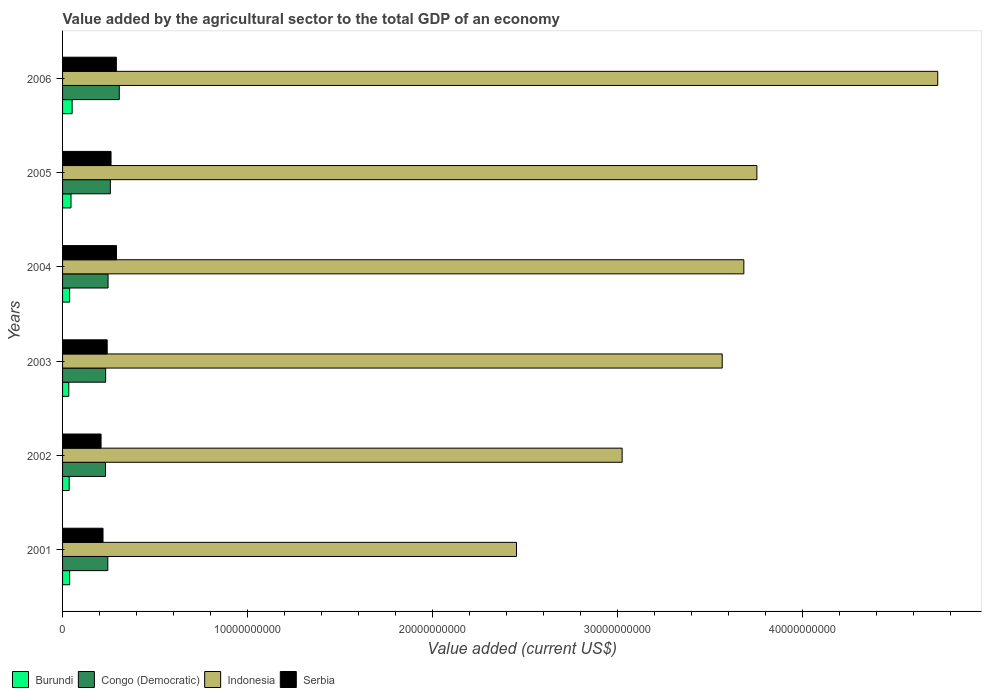How many different coloured bars are there?
Provide a succinct answer. 4. Are the number of bars per tick equal to the number of legend labels?
Your answer should be compact. Yes. What is the label of the 4th group of bars from the top?
Make the answer very short. 2003. In how many cases, is the number of bars for a given year not equal to the number of legend labels?
Keep it short and to the point. 0. What is the value added by the agricultural sector to the total GDP in Burundi in 2002?
Provide a succinct answer. 3.58e+08. Across all years, what is the maximum value added by the agricultural sector to the total GDP in Burundi?
Keep it short and to the point. 5.17e+08. Across all years, what is the minimum value added by the agricultural sector to the total GDP in Serbia?
Ensure brevity in your answer.  2.08e+09. In which year was the value added by the agricultural sector to the total GDP in Indonesia minimum?
Offer a terse response. 2001. What is the total value added by the agricultural sector to the total GDP in Serbia in the graph?
Offer a terse response. 1.51e+1. What is the difference between the value added by the agricultural sector to the total GDP in Serbia in 2001 and that in 2005?
Your answer should be very brief. -4.33e+08. What is the difference between the value added by the agricultural sector to the total GDP in Indonesia in 2001 and the value added by the agricultural sector to the total GDP in Serbia in 2003?
Give a very brief answer. 2.21e+1. What is the average value added by the agricultural sector to the total GDP in Indonesia per year?
Provide a succinct answer. 3.53e+1. In the year 2004, what is the difference between the value added by the agricultural sector to the total GDP in Indonesia and value added by the agricultural sector to the total GDP in Congo (Democratic)?
Your answer should be very brief. 3.44e+1. What is the ratio of the value added by the agricultural sector to the total GDP in Burundi in 2001 to that in 2002?
Your answer should be compact. 1.07. Is the value added by the agricultural sector to the total GDP in Burundi in 2004 less than that in 2005?
Make the answer very short. Yes. What is the difference between the highest and the second highest value added by the agricultural sector to the total GDP in Serbia?
Provide a short and direct response. 7.40e+06. What is the difference between the highest and the lowest value added by the agricultural sector to the total GDP in Serbia?
Give a very brief answer. 8.35e+08. In how many years, is the value added by the agricultural sector to the total GDP in Serbia greater than the average value added by the agricultural sector to the total GDP in Serbia taken over all years?
Ensure brevity in your answer.  3. Is the sum of the value added by the agricultural sector to the total GDP in Congo (Democratic) in 2002 and 2003 greater than the maximum value added by the agricultural sector to the total GDP in Indonesia across all years?
Offer a very short reply. No. Is it the case that in every year, the sum of the value added by the agricultural sector to the total GDP in Indonesia and value added by the agricultural sector to the total GDP in Congo (Democratic) is greater than the sum of value added by the agricultural sector to the total GDP in Burundi and value added by the agricultural sector to the total GDP in Serbia?
Offer a terse response. Yes. What does the 2nd bar from the top in 2001 represents?
Offer a terse response. Indonesia. Is it the case that in every year, the sum of the value added by the agricultural sector to the total GDP in Serbia and value added by the agricultural sector to the total GDP in Congo (Democratic) is greater than the value added by the agricultural sector to the total GDP in Burundi?
Your answer should be very brief. Yes. How many years are there in the graph?
Give a very brief answer. 6. What is the difference between two consecutive major ticks on the X-axis?
Give a very brief answer. 1.00e+1. How many legend labels are there?
Your answer should be very brief. 4. What is the title of the graph?
Offer a very short reply. Value added by the agricultural sector to the total GDP of an economy. What is the label or title of the X-axis?
Your response must be concise. Value added (current US$). What is the label or title of the Y-axis?
Offer a very short reply. Years. What is the Value added (current US$) in Burundi in 2001?
Give a very brief answer. 3.84e+08. What is the Value added (current US$) in Congo (Democratic) in 2001?
Provide a succinct answer. 2.44e+09. What is the Value added (current US$) in Indonesia in 2001?
Your answer should be very brief. 2.45e+1. What is the Value added (current US$) in Serbia in 2001?
Offer a terse response. 2.19e+09. What is the Value added (current US$) in Burundi in 2002?
Your answer should be compact. 3.58e+08. What is the Value added (current US$) in Congo (Democratic) in 2002?
Provide a short and direct response. 2.32e+09. What is the Value added (current US$) of Indonesia in 2002?
Your answer should be very brief. 3.02e+1. What is the Value added (current US$) of Serbia in 2002?
Give a very brief answer. 2.08e+09. What is the Value added (current US$) of Burundi in 2003?
Make the answer very short. 3.36e+08. What is the Value added (current US$) of Congo (Democratic) in 2003?
Your response must be concise. 2.33e+09. What is the Value added (current US$) in Indonesia in 2003?
Provide a short and direct response. 3.57e+1. What is the Value added (current US$) in Serbia in 2003?
Keep it short and to the point. 2.41e+09. What is the Value added (current US$) of Burundi in 2004?
Your response must be concise. 3.84e+08. What is the Value added (current US$) in Congo (Democratic) in 2004?
Make the answer very short. 2.46e+09. What is the Value added (current US$) of Indonesia in 2004?
Give a very brief answer. 3.68e+1. What is the Value added (current US$) in Serbia in 2004?
Provide a short and direct response. 2.92e+09. What is the Value added (current US$) of Burundi in 2005?
Your answer should be very brief. 4.56e+08. What is the Value added (current US$) of Congo (Democratic) in 2005?
Offer a terse response. 2.58e+09. What is the Value added (current US$) in Indonesia in 2005?
Ensure brevity in your answer.  3.75e+1. What is the Value added (current US$) of Serbia in 2005?
Ensure brevity in your answer.  2.62e+09. What is the Value added (current US$) in Burundi in 2006?
Provide a short and direct response. 5.17e+08. What is the Value added (current US$) in Congo (Democratic) in 2006?
Offer a terse response. 3.07e+09. What is the Value added (current US$) in Indonesia in 2006?
Keep it short and to the point. 4.73e+1. What is the Value added (current US$) of Serbia in 2006?
Ensure brevity in your answer.  2.91e+09. Across all years, what is the maximum Value added (current US$) of Burundi?
Your response must be concise. 5.17e+08. Across all years, what is the maximum Value added (current US$) of Congo (Democratic)?
Offer a very short reply. 3.07e+09. Across all years, what is the maximum Value added (current US$) of Indonesia?
Keep it short and to the point. 4.73e+1. Across all years, what is the maximum Value added (current US$) of Serbia?
Give a very brief answer. 2.92e+09. Across all years, what is the minimum Value added (current US$) in Burundi?
Provide a succinct answer. 3.36e+08. Across all years, what is the minimum Value added (current US$) of Congo (Democratic)?
Provide a short and direct response. 2.32e+09. Across all years, what is the minimum Value added (current US$) of Indonesia?
Your response must be concise. 2.45e+1. Across all years, what is the minimum Value added (current US$) of Serbia?
Ensure brevity in your answer.  2.08e+09. What is the total Value added (current US$) of Burundi in the graph?
Offer a very short reply. 2.44e+09. What is the total Value added (current US$) of Congo (Democratic) in the graph?
Give a very brief answer. 1.52e+1. What is the total Value added (current US$) in Indonesia in the graph?
Give a very brief answer. 2.12e+11. What is the total Value added (current US$) of Serbia in the graph?
Your response must be concise. 1.51e+1. What is the difference between the Value added (current US$) in Burundi in 2001 and that in 2002?
Your answer should be very brief. 2.67e+07. What is the difference between the Value added (current US$) of Congo (Democratic) in 2001 and that in 2002?
Give a very brief answer. 1.25e+08. What is the difference between the Value added (current US$) in Indonesia in 2001 and that in 2002?
Offer a terse response. -5.71e+09. What is the difference between the Value added (current US$) in Serbia in 2001 and that in 2002?
Your answer should be compact. 1.06e+08. What is the difference between the Value added (current US$) in Burundi in 2001 and that in 2003?
Offer a terse response. 4.83e+07. What is the difference between the Value added (current US$) in Congo (Democratic) in 2001 and that in 2003?
Give a very brief answer. 1.16e+08. What is the difference between the Value added (current US$) of Indonesia in 2001 and that in 2003?
Ensure brevity in your answer.  -1.11e+1. What is the difference between the Value added (current US$) in Serbia in 2001 and that in 2003?
Give a very brief answer. -2.26e+08. What is the difference between the Value added (current US$) of Burundi in 2001 and that in 2004?
Make the answer very short. 8.98e+05. What is the difference between the Value added (current US$) of Congo (Democratic) in 2001 and that in 2004?
Your response must be concise. -1.40e+07. What is the difference between the Value added (current US$) of Indonesia in 2001 and that in 2004?
Provide a succinct answer. -1.23e+1. What is the difference between the Value added (current US$) in Serbia in 2001 and that in 2004?
Offer a very short reply. -7.29e+08. What is the difference between the Value added (current US$) in Burundi in 2001 and that in 2005?
Provide a succinct answer. -7.20e+07. What is the difference between the Value added (current US$) of Congo (Democratic) in 2001 and that in 2005?
Give a very brief answer. -1.37e+08. What is the difference between the Value added (current US$) of Indonesia in 2001 and that in 2005?
Keep it short and to the point. -1.30e+1. What is the difference between the Value added (current US$) of Serbia in 2001 and that in 2005?
Give a very brief answer. -4.33e+08. What is the difference between the Value added (current US$) of Burundi in 2001 and that in 2006?
Provide a short and direct response. -1.33e+08. What is the difference between the Value added (current US$) of Congo (Democratic) in 2001 and that in 2006?
Provide a short and direct response. -6.20e+08. What is the difference between the Value added (current US$) of Indonesia in 2001 and that in 2006?
Your response must be concise. -2.28e+1. What is the difference between the Value added (current US$) in Serbia in 2001 and that in 2006?
Keep it short and to the point. -7.22e+08. What is the difference between the Value added (current US$) in Burundi in 2002 and that in 2003?
Provide a short and direct response. 2.15e+07. What is the difference between the Value added (current US$) in Congo (Democratic) in 2002 and that in 2003?
Your answer should be very brief. -8.34e+06. What is the difference between the Value added (current US$) of Indonesia in 2002 and that in 2003?
Provide a short and direct response. -5.41e+09. What is the difference between the Value added (current US$) of Serbia in 2002 and that in 2003?
Ensure brevity in your answer.  -3.32e+08. What is the difference between the Value added (current US$) of Burundi in 2002 and that in 2004?
Ensure brevity in your answer.  -2.58e+07. What is the difference between the Value added (current US$) in Congo (Democratic) in 2002 and that in 2004?
Keep it short and to the point. -1.39e+08. What is the difference between the Value added (current US$) in Indonesia in 2002 and that in 2004?
Your answer should be compact. -6.58e+09. What is the difference between the Value added (current US$) of Serbia in 2002 and that in 2004?
Ensure brevity in your answer.  -8.35e+08. What is the difference between the Value added (current US$) in Burundi in 2002 and that in 2005?
Your response must be concise. -9.87e+07. What is the difference between the Value added (current US$) of Congo (Democratic) in 2002 and that in 2005?
Provide a succinct answer. -2.62e+08. What is the difference between the Value added (current US$) in Indonesia in 2002 and that in 2005?
Provide a succinct answer. -7.28e+09. What is the difference between the Value added (current US$) in Serbia in 2002 and that in 2005?
Give a very brief answer. -5.39e+08. What is the difference between the Value added (current US$) in Burundi in 2002 and that in 2006?
Your answer should be very brief. -1.60e+08. What is the difference between the Value added (current US$) of Congo (Democratic) in 2002 and that in 2006?
Make the answer very short. -7.45e+08. What is the difference between the Value added (current US$) of Indonesia in 2002 and that in 2006?
Make the answer very short. -1.71e+1. What is the difference between the Value added (current US$) in Serbia in 2002 and that in 2006?
Provide a short and direct response. -8.27e+08. What is the difference between the Value added (current US$) of Burundi in 2003 and that in 2004?
Offer a terse response. -4.74e+07. What is the difference between the Value added (current US$) in Congo (Democratic) in 2003 and that in 2004?
Your response must be concise. -1.30e+08. What is the difference between the Value added (current US$) in Indonesia in 2003 and that in 2004?
Give a very brief answer. -1.17e+09. What is the difference between the Value added (current US$) in Serbia in 2003 and that in 2004?
Keep it short and to the point. -5.03e+08. What is the difference between the Value added (current US$) of Burundi in 2003 and that in 2005?
Give a very brief answer. -1.20e+08. What is the difference between the Value added (current US$) of Congo (Democratic) in 2003 and that in 2005?
Your response must be concise. -2.53e+08. What is the difference between the Value added (current US$) in Indonesia in 2003 and that in 2005?
Ensure brevity in your answer.  -1.87e+09. What is the difference between the Value added (current US$) in Serbia in 2003 and that in 2005?
Ensure brevity in your answer.  -2.07e+08. What is the difference between the Value added (current US$) in Burundi in 2003 and that in 2006?
Your answer should be compact. -1.81e+08. What is the difference between the Value added (current US$) in Congo (Democratic) in 2003 and that in 2006?
Provide a short and direct response. -7.37e+08. What is the difference between the Value added (current US$) in Indonesia in 2003 and that in 2006?
Give a very brief answer. -1.16e+1. What is the difference between the Value added (current US$) of Serbia in 2003 and that in 2006?
Give a very brief answer. -4.96e+08. What is the difference between the Value added (current US$) of Burundi in 2004 and that in 2005?
Make the answer very short. -7.29e+07. What is the difference between the Value added (current US$) in Congo (Democratic) in 2004 and that in 2005?
Your response must be concise. -1.23e+08. What is the difference between the Value added (current US$) in Indonesia in 2004 and that in 2005?
Provide a short and direct response. -7.05e+08. What is the difference between the Value added (current US$) in Serbia in 2004 and that in 2005?
Give a very brief answer. 2.96e+08. What is the difference between the Value added (current US$) of Burundi in 2004 and that in 2006?
Your answer should be very brief. -1.34e+08. What is the difference between the Value added (current US$) in Congo (Democratic) in 2004 and that in 2006?
Give a very brief answer. -6.06e+08. What is the difference between the Value added (current US$) of Indonesia in 2004 and that in 2006?
Give a very brief answer. -1.05e+1. What is the difference between the Value added (current US$) of Serbia in 2004 and that in 2006?
Offer a very short reply. 7.40e+06. What is the difference between the Value added (current US$) of Burundi in 2005 and that in 2006?
Ensure brevity in your answer.  -6.11e+07. What is the difference between the Value added (current US$) of Congo (Democratic) in 2005 and that in 2006?
Give a very brief answer. -4.83e+08. What is the difference between the Value added (current US$) in Indonesia in 2005 and that in 2006?
Give a very brief answer. -9.77e+09. What is the difference between the Value added (current US$) of Serbia in 2005 and that in 2006?
Your response must be concise. -2.88e+08. What is the difference between the Value added (current US$) in Burundi in 2001 and the Value added (current US$) in Congo (Democratic) in 2002?
Ensure brevity in your answer.  -1.94e+09. What is the difference between the Value added (current US$) of Burundi in 2001 and the Value added (current US$) of Indonesia in 2002?
Give a very brief answer. -2.99e+1. What is the difference between the Value added (current US$) in Burundi in 2001 and the Value added (current US$) in Serbia in 2002?
Make the answer very short. -1.70e+09. What is the difference between the Value added (current US$) in Congo (Democratic) in 2001 and the Value added (current US$) in Indonesia in 2002?
Offer a terse response. -2.78e+1. What is the difference between the Value added (current US$) of Congo (Democratic) in 2001 and the Value added (current US$) of Serbia in 2002?
Your answer should be very brief. 3.65e+08. What is the difference between the Value added (current US$) of Indonesia in 2001 and the Value added (current US$) of Serbia in 2002?
Ensure brevity in your answer.  2.25e+1. What is the difference between the Value added (current US$) of Burundi in 2001 and the Value added (current US$) of Congo (Democratic) in 2003?
Provide a succinct answer. -1.94e+09. What is the difference between the Value added (current US$) in Burundi in 2001 and the Value added (current US$) in Indonesia in 2003?
Provide a succinct answer. -3.53e+1. What is the difference between the Value added (current US$) in Burundi in 2001 and the Value added (current US$) in Serbia in 2003?
Your answer should be very brief. -2.03e+09. What is the difference between the Value added (current US$) in Congo (Democratic) in 2001 and the Value added (current US$) in Indonesia in 2003?
Offer a very short reply. -3.32e+1. What is the difference between the Value added (current US$) of Congo (Democratic) in 2001 and the Value added (current US$) of Serbia in 2003?
Give a very brief answer. 3.29e+07. What is the difference between the Value added (current US$) in Indonesia in 2001 and the Value added (current US$) in Serbia in 2003?
Provide a succinct answer. 2.21e+1. What is the difference between the Value added (current US$) in Burundi in 2001 and the Value added (current US$) in Congo (Democratic) in 2004?
Your response must be concise. -2.07e+09. What is the difference between the Value added (current US$) of Burundi in 2001 and the Value added (current US$) of Indonesia in 2004?
Make the answer very short. -3.64e+1. What is the difference between the Value added (current US$) in Burundi in 2001 and the Value added (current US$) in Serbia in 2004?
Give a very brief answer. -2.53e+09. What is the difference between the Value added (current US$) of Congo (Democratic) in 2001 and the Value added (current US$) of Indonesia in 2004?
Keep it short and to the point. -3.44e+1. What is the difference between the Value added (current US$) of Congo (Democratic) in 2001 and the Value added (current US$) of Serbia in 2004?
Your answer should be compact. -4.70e+08. What is the difference between the Value added (current US$) of Indonesia in 2001 and the Value added (current US$) of Serbia in 2004?
Provide a short and direct response. 2.16e+1. What is the difference between the Value added (current US$) in Burundi in 2001 and the Value added (current US$) in Congo (Democratic) in 2005?
Provide a succinct answer. -2.20e+09. What is the difference between the Value added (current US$) in Burundi in 2001 and the Value added (current US$) in Indonesia in 2005?
Your response must be concise. -3.71e+1. What is the difference between the Value added (current US$) in Burundi in 2001 and the Value added (current US$) in Serbia in 2005?
Ensure brevity in your answer.  -2.24e+09. What is the difference between the Value added (current US$) in Congo (Democratic) in 2001 and the Value added (current US$) in Indonesia in 2005?
Your answer should be very brief. -3.51e+1. What is the difference between the Value added (current US$) in Congo (Democratic) in 2001 and the Value added (current US$) in Serbia in 2005?
Offer a terse response. -1.75e+08. What is the difference between the Value added (current US$) of Indonesia in 2001 and the Value added (current US$) of Serbia in 2005?
Give a very brief answer. 2.19e+1. What is the difference between the Value added (current US$) in Burundi in 2001 and the Value added (current US$) in Congo (Democratic) in 2006?
Make the answer very short. -2.68e+09. What is the difference between the Value added (current US$) of Burundi in 2001 and the Value added (current US$) of Indonesia in 2006?
Make the answer very short. -4.69e+1. What is the difference between the Value added (current US$) in Burundi in 2001 and the Value added (current US$) in Serbia in 2006?
Offer a terse response. -2.52e+09. What is the difference between the Value added (current US$) of Congo (Democratic) in 2001 and the Value added (current US$) of Indonesia in 2006?
Keep it short and to the point. -4.49e+1. What is the difference between the Value added (current US$) in Congo (Democratic) in 2001 and the Value added (current US$) in Serbia in 2006?
Provide a short and direct response. -4.63e+08. What is the difference between the Value added (current US$) in Indonesia in 2001 and the Value added (current US$) in Serbia in 2006?
Offer a terse response. 2.16e+1. What is the difference between the Value added (current US$) of Burundi in 2002 and the Value added (current US$) of Congo (Democratic) in 2003?
Make the answer very short. -1.97e+09. What is the difference between the Value added (current US$) in Burundi in 2002 and the Value added (current US$) in Indonesia in 2003?
Give a very brief answer. -3.53e+1. What is the difference between the Value added (current US$) of Burundi in 2002 and the Value added (current US$) of Serbia in 2003?
Provide a short and direct response. -2.05e+09. What is the difference between the Value added (current US$) in Congo (Democratic) in 2002 and the Value added (current US$) in Indonesia in 2003?
Provide a short and direct response. -3.33e+1. What is the difference between the Value added (current US$) in Congo (Democratic) in 2002 and the Value added (current US$) in Serbia in 2003?
Provide a succinct answer. -9.18e+07. What is the difference between the Value added (current US$) of Indonesia in 2002 and the Value added (current US$) of Serbia in 2003?
Make the answer very short. 2.78e+1. What is the difference between the Value added (current US$) of Burundi in 2002 and the Value added (current US$) of Congo (Democratic) in 2004?
Give a very brief answer. -2.10e+09. What is the difference between the Value added (current US$) in Burundi in 2002 and the Value added (current US$) in Indonesia in 2004?
Keep it short and to the point. -3.65e+1. What is the difference between the Value added (current US$) in Burundi in 2002 and the Value added (current US$) in Serbia in 2004?
Provide a short and direct response. -2.56e+09. What is the difference between the Value added (current US$) of Congo (Democratic) in 2002 and the Value added (current US$) of Indonesia in 2004?
Ensure brevity in your answer.  -3.45e+1. What is the difference between the Value added (current US$) in Congo (Democratic) in 2002 and the Value added (current US$) in Serbia in 2004?
Offer a terse response. -5.95e+08. What is the difference between the Value added (current US$) in Indonesia in 2002 and the Value added (current US$) in Serbia in 2004?
Your answer should be very brief. 2.73e+1. What is the difference between the Value added (current US$) in Burundi in 2002 and the Value added (current US$) in Congo (Democratic) in 2005?
Ensure brevity in your answer.  -2.22e+09. What is the difference between the Value added (current US$) of Burundi in 2002 and the Value added (current US$) of Indonesia in 2005?
Offer a very short reply. -3.72e+1. What is the difference between the Value added (current US$) in Burundi in 2002 and the Value added (current US$) in Serbia in 2005?
Your response must be concise. -2.26e+09. What is the difference between the Value added (current US$) in Congo (Democratic) in 2002 and the Value added (current US$) in Indonesia in 2005?
Provide a succinct answer. -3.52e+1. What is the difference between the Value added (current US$) of Congo (Democratic) in 2002 and the Value added (current US$) of Serbia in 2005?
Provide a succinct answer. -2.99e+08. What is the difference between the Value added (current US$) in Indonesia in 2002 and the Value added (current US$) in Serbia in 2005?
Offer a very short reply. 2.76e+1. What is the difference between the Value added (current US$) in Burundi in 2002 and the Value added (current US$) in Congo (Democratic) in 2006?
Provide a short and direct response. -2.71e+09. What is the difference between the Value added (current US$) in Burundi in 2002 and the Value added (current US$) in Indonesia in 2006?
Offer a very short reply. -4.69e+1. What is the difference between the Value added (current US$) of Burundi in 2002 and the Value added (current US$) of Serbia in 2006?
Give a very brief answer. -2.55e+09. What is the difference between the Value added (current US$) of Congo (Democratic) in 2002 and the Value added (current US$) of Indonesia in 2006?
Make the answer very short. -4.50e+1. What is the difference between the Value added (current US$) in Congo (Democratic) in 2002 and the Value added (current US$) in Serbia in 2006?
Your answer should be compact. -5.87e+08. What is the difference between the Value added (current US$) in Indonesia in 2002 and the Value added (current US$) in Serbia in 2006?
Offer a very short reply. 2.73e+1. What is the difference between the Value added (current US$) in Burundi in 2003 and the Value added (current US$) in Congo (Democratic) in 2004?
Your answer should be very brief. -2.12e+09. What is the difference between the Value added (current US$) of Burundi in 2003 and the Value added (current US$) of Indonesia in 2004?
Offer a terse response. -3.65e+1. What is the difference between the Value added (current US$) in Burundi in 2003 and the Value added (current US$) in Serbia in 2004?
Make the answer very short. -2.58e+09. What is the difference between the Value added (current US$) of Congo (Democratic) in 2003 and the Value added (current US$) of Indonesia in 2004?
Give a very brief answer. -3.45e+1. What is the difference between the Value added (current US$) of Congo (Democratic) in 2003 and the Value added (current US$) of Serbia in 2004?
Keep it short and to the point. -5.86e+08. What is the difference between the Value added (current US$) in Indonesia in 2003 and the Value added (current US$) in Serbia in 2004?
Your response must be concise. 3.27e+1. What is the difference between the Value added (current US$) in Burundi in 2003 and the Value added (current US$) in Congo (Democratic) in 2005?
Keep it short and to the point. -2.25e+09. What is the difference between the Value added (current US$) in Burundi in 2003 and the Value added (current US$) in Indonesia in 2005?
Give a very brief answer. -3.72e+1. What is the difference between the Value added (current US$) in Burundi in 2003 and the Value added (current US$) in Serbia in 2005?
Ensure brevity in your answer.  -2.28e+09. What is the difference between the Value added (current US$) in Congo (Democratic) in 2003 and the Value added (current US$) in Indonesia in 2005?
Your response must be concise. -3.52e+1. What is the difference between the Value added (current US$) in Congo (Democratic) in 2003 and the Value added (current US$) in Serbia in 2005?
Make the answer very short. -2.91e+08. What is the difference between the Value added (current US$) of Indonesia in 2003 and the Value added (current US$) of Serbia in 2005?
Your response must be concise. 3.30e+1. What is the difference between the Value added (current US$) in Burundi in 2003 and the Value added (current US$) in Congo (Democratic) in 2006?
Your answer should be compact. -2.73e+09. What is the difference between the Value added (current US$) in Burundi in 2003 and the Value added (current US$) in Indonesia in 2006?
Give a very brief answer. -4.70e+1. What is the difference between the Value added (current US$) of Burundi in 2003 and the Value added (current US$) of Serbia in 2006?
Make the answer very short. -2.57e+09. What is the difference between the Value added (current US$) of Congo (Democratic) in 2003 and the Value added (current US$) of Indonesia in 2006?
Your answer should be very brief. -4.50e+1. What is the difference between the Value added (current US$) in Congo (Democratic) in 2003 and the Value added (current US$) in Serbia in 2006?
Ensure brevity in your answer.  -5.79e+08. What is the difference between the Value added (current US$) in Indonesia in 2003 and the Value added (current US$) in Serbia in 2006?
Your answer should be very brief. 3.27e+1. What is the difference between the Value added (current US$) of Burundi in 2004 and the Value added (current US$) of Congo (Democratic) in 2005?
Your answer should be very brief. -2.20e+09. What is the difference between the Value added (current US$) in Burundi in 2004 and the Value added (current US$) in Indonesia in 2005?
Provide a short and direct response. -3.71e+1. What is the difference between the Value added (current US$) of Burundi in 2004 and the Value added (current US$) of Serbia in 2005?
Make the answer very short. -2.24e+09. What is the difference between the Value added (current US$) of Congo (Democratic) in 2004 and the Value added (current US$) of Indonesia in 2005?
Make the answer very short. -3.51e+1. What is the difference between the Value added (current US$) in Congo (Democratic) in 2004 and the Value added (current US$) in Serbia in 2005?
Your response must be concise. -1.61e+08. What is the difference between the Value added (current US$) in Indonesia in 2004 and the Value added (current US$) in Serbia in 2005?
Give a very brief answer. 3.42e+1. What is the difference between the Value added (current US$) in Burundi in 2004 and the Value added (current US$) in Congo (Democratic) in 2006?
Your answer should be very brief. -2.68e+09. What is the difference between the Value added (current US$) in Burundi in 2004 and the Value added (current US$) in Indonesia in 2006?
Your answer should be compact. -4.69e+1. What is the difference between the Value added (current US$) in Burundi in 2004 and the Value added (current US$) in Serbia in 2006?
Keep it short and to the point. -2.52e+09. What is the difference between the Value added (current US$) in Congo (Democratic) in 2004 and the Value added (current US$) in Indonesia in 2006?
Provide a succinct answer. -4.48e+1. What is the difference between the Value added (current US$) of Congo (Democratic) in 2004 and the Value added (current US$) of Serbia in 2006?
Your response must be concise. -4.49e+08. What is the difference between the Value added (current US$) in Indonesia in 2004 and the Value added (current US$) in Serbia in 2006?
Make the answer very short. 3.39e+1. What is the difference between the Value added (current US$) of Burundi in 2005 and the Value added (current US$) of Congo (Democratic) in 2006?
Offer a very short reply. -2.61e+09. What is the difference between the Value added (current US$) of Burundi in 2005 and the Value added (current US$) of Indonesia in 2006?
Provide a short and direct response. -4.68e+1. What is the difference between the Value added (current US$) in Burundi in 2005 and the Value added (current US$) in Serbia in 2006?
Make the answer very short. -2.45e+09. What is the difference between the Value added (current US$) of Congo (Democratic) in 2005 and the Value added (current US$) of Indonesia in 2006?
Provide a succinct answer. -4.47e+1. What is the difference between the Value added (current US$) in Congo (Democratic) in 2005 and the Value added (current US$) in Serbia in 2006?
Keep it short and to the point. -3.26e+08. What is the difference between the Value added (current US$) in Indonesia in 2005 and the Value added (current US$) in Serbia in 2006?
Your answer should be very brief. 3.46e+1. What is the average Value added (current US$) in Burundi per year?
Keep it short and to the point. 4.06e+08. What is the average Value added (current US$) of Congo (Democratic) per year?
Your response must be concise. 2.53e+09. What is the average Value added (current US$) in Indonesia per year?
Give a very brief answer. 3.53e+1. What is the average Value added (current US$) in Serbia per year?
Keep it short and to the point. 2.52e+09. In the year 2001, what is the difference between the Value added (current US$) in Burundi and Value added (current US$) in Congo (Democratic)?
Provide a short and direct response. -2.06e+09. In the year 2001, what is the difference between the Value added (current US$) of Burundi and Value added (current US$) of Indonesia?
Provide a succinct answer. -2.41e+1. In the year 2001, what is the difference between the Value added (current US$) of Burundi and Value added (current US$) of Serbia?
Your answer should be very brief. -1.80e+09. In the year 2001, what is the difference between the Value added (current US$) in Congo (Democratic) and Value added (current US$) in Indonesia?
Your answer should be compact. -2.21e+1. In the year 2001, what is the difference between the Value added (current US$) of Congo (Democratic) and Value added (current US$) of Serbia?
Give a very brief answer. 2.59e+08. In the year 2001, what is the difference between the Value added (current US$) of Indonesia and Value added (current US$) of Serbia?
Give a very brief answer. 2.23e+1. In the year 2002, what is the difference between the Value added (current US$) in Burundi and Value added (current US$) in Congo (Democratic)?
Your response must be concise. -1.96e+09. In the year 2002, what is the difference between the Value added (current US$) of Burundi and Value added (current US$) of Indonesia?
Offer a terse response. -2.99e+1. In the year 2002, what is the difference between the Value added (current US$) of Burundi and Value added (current US$) of Serbia?
Offer a very short reply. -1.72e+09. In the year 2002, what is the difference between the Value added (current US$) of Congo (Democratic) and Value added (current US$) of Indonesia?
Provide a short and direct response. -2.79e+1. In the year 2002, what is the difference between the Value added (current US$) of Congo (Democratic) and Value added (current US$) of Serbia?
Your answer should be compact. 2.40e+08. In the year 2002, what is the difference between the Value added (current US$) in Indonesia and Value added (current US$) in Serbia?
Your answer should be compact. 2.82e+1. In the year 2003, what is the difference between the Value added (current US$) of Burundi and Value added (current US$) of Congo (Democratic)?
Ensure brevity in your answer.  -1.99e+09. In the year 2003, what is the difference between the Value added (current US$) in Burundi and Value added (current US$) in Indonesia?
Offer a very short reply. -3.53e+1. In the year 2003, what is the difference between the Value added (current US$) in Burundi and Value added (current US$) in Serbia?
Offer a terse response. -2.08e+09. In the year 2003, what is the difference between the Value added (current US$) in Congo (Democratic) and Value added (current US$) in Indonesia?
Ensure brevity in your answer.  -3.33e+1. In the year 2003, what is the difference between the Value added (current US$) in Congo (Democratic) and Value added (current US$) in Serbia?
Ensure brevity in your answer.  -8.35e+07. In the year 2003, what is the difference between the Value added (current US$) in Indonesia and Value added (current US$) in Serbia?
Ensure brevity in your answer.  3.32e+1. In the year 2004, what is the difference between the Value added (current US$) of Burundi and Value added (current US$) of Congo (Democratic)?
Your response must be concise. -2.08e+09. In the year 2004, what is the difference between the Value added (current US$) in Burundi and Value added (current US$) in Indonesia?
Offer a very short reply. -3.64e+1. In the year 2004, what is the difference between the Value added (current US$) in Burundi and Value added (current US$) in Serbia?
Keep it short and to the point. -2.53e+09. In the year 2004, what is the difference between the Value added (current US$) in Congo (Democratic) and Value added (current US$) in Indonesia?
Give a very brief answer. -3.44e+1. In the year 2004, what is the difference between the Value added (current US$) of Congo (Democratic) and Value added (current US$) of Serbia?
Offer a very short reply. -4.56e+08. In the year 2004, what is the difference between the Value added (current US$) in Indonesia and Value added (current US$) in Serbia?
Your answer should be compact. 3.39e+1. In the year 2005, what is the difference between the Value added (current US$) of Burundi and Value added (current US$) of Congo (Democratic)?
Provide a succinct answer. -2.13e+09. In the year 2005, what is the difference between the Value added (current US$) of Burundi and Value added (current US$) of Indonesia?
Your answer should be compact. -3.71e+1. In the year 2005, what is the difference between the Value added (current US$) in Burundi and Value added (current US$) in Serbia?
Your answer should be compact. -2.16e+09. In the year 2005, what is the difference between the Value added (current US$) of Congo (Democratic) and Value added (current US$) of Indonesia?
Keep it short and to the point. -3.49e+1. In the year 2005, what is the difference between the Value added (current US$) of Congo (Democratic) and Value added (current US$) of Serbia?
Ensure brevity in your answer.  -3.76e+07. In the year 2005, what is the difference between the Value added (current US$) of Indonesia and Value added (current US$) of Serbia?
Give a very brief answer. 3.49e+1. In the year 2006, what is the difference between the Value added (current US$) of Burundi and Value added (current US$) of Congo (Democratic)?
Offer a very short reply. -2.55e+09. In the year 2006, what is the difference between the Value added (current US$) in Burundi and Value added (current US$) in Indonesia?
Your answer should be compact. -4.68e+1. In the year 2006, what is the difference between the Value added (current US$) in Burundi and Value added (current US$) in Serbia?
Provide a short and direct response. -2.39e+09. In the year 2006, what is the difference between the Value added (current US$) of Congo (Democratic) and Value added (current US$) of Indonesia?
Offer a terse response. -4.42e+1. In the year 2006, what is the difference between the Value added (current US$) in Congo (Democratic) and Value added (current US$) in Serbia?
Offer a very short reply. 1.58e+08. In the year 2006, what is the difference between the Value added (current US$) of Indonesia and Value added (current US$) of Serbia?
Offer a very short reply. 4.44e+1. What is the ratio of the Value added (current US$) of Burundi in 2001 to that in 2002?
Your answer should be compact. 1.07. What is the ratio of the Value added (current US$) in Congo (Democratic) in 2001 to that in 2002?
Your response must be concise. 1.05. What is the ratio of the Value added (current US$) in Indonesia in 2001 to that in 2002?
Keep it short and to the point. 0.81. What is the ratio of the Value added (current US$) of Serbia in 2001 to that in 2002?
Offer a very short reply. 1.05. What is the ratio of the Value added (current US$) in Burundi in 2001 to that in 2003?
Your response must be concise. 1.14. What is the ratio of the Value added (current US$) in Congo (Democratic) in 2001 to that in 2003?
Provide a short and direct response. 1.05. What is the ratio of the Value added (current US$) in Indonesia in 2001 to that in 2003?
Your response must be concise. 0.69. What is the ratio of the Value added (current US$) in Serbia in 2001 to that in 2003?
Keep it short and to the point. 0.91. What is the ratio of the Value added (current US$) in Indonesia in 2001 to that in 2004?
Offer a very short reply. 0.67. What is the ratio of the Value added (current US$) in Serbia in 2001 to that in 2004?
Offer a terse response. 0.75. What is the ratio of the Value added (current US$) of Burundi in 2001 to that in 2005?
Provide a succinct answer. 0.84. What is the ratio of the Value added (current US$) of Congo (Democratic) in 2001 to that in 2005?
Ensure brevity in your answer.  0.95. What is the ratio of the Value added (current US$) in Indonesia in 2001 to that in 2005?
Provide a succinct answer. 0.65. What is the ratio of the Value added (current US$) of Serbia in 2001 to that in 2005?
Offer a very short reply. 0.83. What is the ratio of the Value added (current US$) of Burundi in 2001 to that in 2006?
Keep it short and to the point. 0.74. What is the ratio of the Value added (current US$) of Congo (Democratic) in 2001 to that in 2006?
Provide a succinct answer. 0.8. What is the ratio of the Value added (current US$) of Indonesia in 2001 to that in 2006?
Your response must be concise. 0.52. What is the ratio of the Value added (current US$) of Serbia in 2001 to that in 2006?
Provide a succinct answer. 0.75. What is the ratio of the Value added (current US$) of Burundi in 2002 to that in 2003?
Make the answer very short. 1.06. What is the ratio of the Value added (current US$) of Congo (Democratic) in 2002 to that in 2003?
Provide a short and direct response. 1. What is the ratio of the Value added (current US$) in Indonesia in 2002 to that in 2003?
Offer a terse response. 0.85. What is the ratio of the Value added (current US$) in Serbia in 2002 to that in 2003?
Your response must be concise. 0.86. What is the ratio of the Value added (current US$) of Burundi in 2002 to that in 2004?
Your answer should be compact. 0.93. What is the ratio of the Value added (current US$) of Congo (Democratic) in 2002 to that in 2004?
Offer a terse response. 0.94. What is the ratio of the Value added (current US$) in Indonesia in 2002 to that in 2004?
Offer a very short reply. 0.82. What is the ratio of the Value added (current US$) in Serbia in 2002 to that in 2004?
Provide a short and direct response. 0.71. What is the ratio of the Value added (current US$) of Burundi in 2002 to that in 2005?
Provide a succinct answer. 0.78. What is the ratio of the Value added (current US$) of Congo (Democratic) in 2002 to that in 2005?
Give a very brief answer. 0.9. What is the ratio of the Value added (current US$) in Indonesia in 2002 to that in 2005?
Give a very brief answer. 0.81. What is the ratio of the Value added (current US$) of Serbia in 2002 to that in 2005?
Keep it short and to the point. 0.79. What is the ratio of the Value added (current US$) in Burundi in 2002 to that in 2006?
Offer a very short reply. 0.69. What is the ratio of the Value added (current US$) of Congo (Democratic) in 2002 to that in 2006?
Give a very brief answer. 0.76. What is the ratio of the Value added (current US$) in Indonesia in 2002 to that in 2006?
Offer a very short reply. 0.64. What is the ratio of the Value added (current US$) of Serbia in 2002 to that in 2006?
Provide a succinct answer. 0.72. What is the ratio of the Value added (current US$) in Burundi in 2003 to that in 2004?
Provide a succinct answer. 0.88. What is the ratio of the Value added (current US$) in Congo (Democratic) in 2003 to that in 2004?
Offer a terse response. 0.95. What is the ratio of the Value added (current US$) of Indonesia in 2003 to that in 2004?
Your response must be concise. 0.97. What is the ratio of the Value added (current US$) of Serbia in 2003 to that in 2004?
Make the answer very short. 0.83. What is the ratio of the Value added (current US$) of Burundi in 2003 to that in 2005?
Keep it short and to the point. 0.74. What is the ratio of the Value added (current US$) of Congo (Democratic) in 2003 to that in 2005?
Your answer should be compact. 0.9. What is the ratio of the Value added (current US$) in Indonesia in 2003 to that in 2005?
Offer a terse response. 0.95. What is the ratio of the Value added (current US$) of Serbia in 2003 to that in 2005?
Offer a very short reply. 0.92. What is the ratio of the Value added (current US$) in Burundi in 2003 to that in 2006?
Your answer should be very brief. 0.65. What is the ratio of the Value added (current US$) in Congo (Democratic) in 2003 to that in 2006?
Make the answer very short. 0.76. What is the ratio of the Value added (current US$) in Indonesia in 2003 to that in 2006?
Your answer should be compact. 0.75. What is the ratio of the Value added (current US$) in Serbia in 2003 to that in 2006?
Offer a very short reply. 0.83. What is the ratio of the Value added (current US$) in Burundi in 2004 to that in 2005?
Give a very brief answer. 0.84. What is the ratio of the Value added (current US$) in Indonesia in 2004 to that in 2005?
Give a very brief answer. 0.98. What is the ratio of the Value added (current US$) of Serbia in 2004 to that in 2005?
Keep it short and to the point. 1.11. What is the ratio of the Value added (current US$) of Burundi in 2004 to that in 2006?
Your response must be concise. 0.74. What is the ratio of the Value added (current US$) of Congo (Democratic) in 2004 to that in 2006?
Your answer should be compact. 0.8. What is the ratio of the Value added (current US$) of Indonesia in 2004 to that in 2006?
Offer a terse response. 0.78. What is the ratio of the Value added (current US$) of Burundi in 2005 to that in 2006?
Keep it short and to the point. 0.88. What is the ratio of the Value added (current US$) in Congo (Democratic) in 2005 to that in 2006?
Ensure brevity in your answer.  0.84. What is the ratio of the Value added (current US$) in Indonesia in 2005 to that in 2006?
Your response must be concise. 0.79. What is the ratio of the Value added (current US$) in Serbia in 2005 to that in 2006?
Ensure brevity in your answer.  0.9. What is the difference between the highest and the second highest Value added (current US$) of Burundi?
Your response must be concise. 6.11e+07. What is the difference between the highest and the second highest Value added (current US$) of Congo (Democratic)?
Keep it short and to the point. 4.83e+08. What is the difference between the highest and the second highest Value added (current US$) in Indonesia?
Your answer should be compact. 9.77e+09. What is the difference between the highest and the second highest Value added (current US$) of Serbia?
Offer a terse response. 7.40e+06. What is the difference between the highest and the lowest Value added (current US$) in Burundi?
Ensure brevity in your answer.  1.81e+08. What is the difference between the highest and the lowest Value added (current US$) in Congo (Democratic)?
Keep it short and to the point. 7.45e+08. What is the difference between the highest and the lowest Value added (current US$) in Indonesia?
Your answer should be very brief. 2.28e+1. What is the difference between the highest and the lowest Value added (current US$) of Serbia?
Make the answer very short. 8.35e+08. 